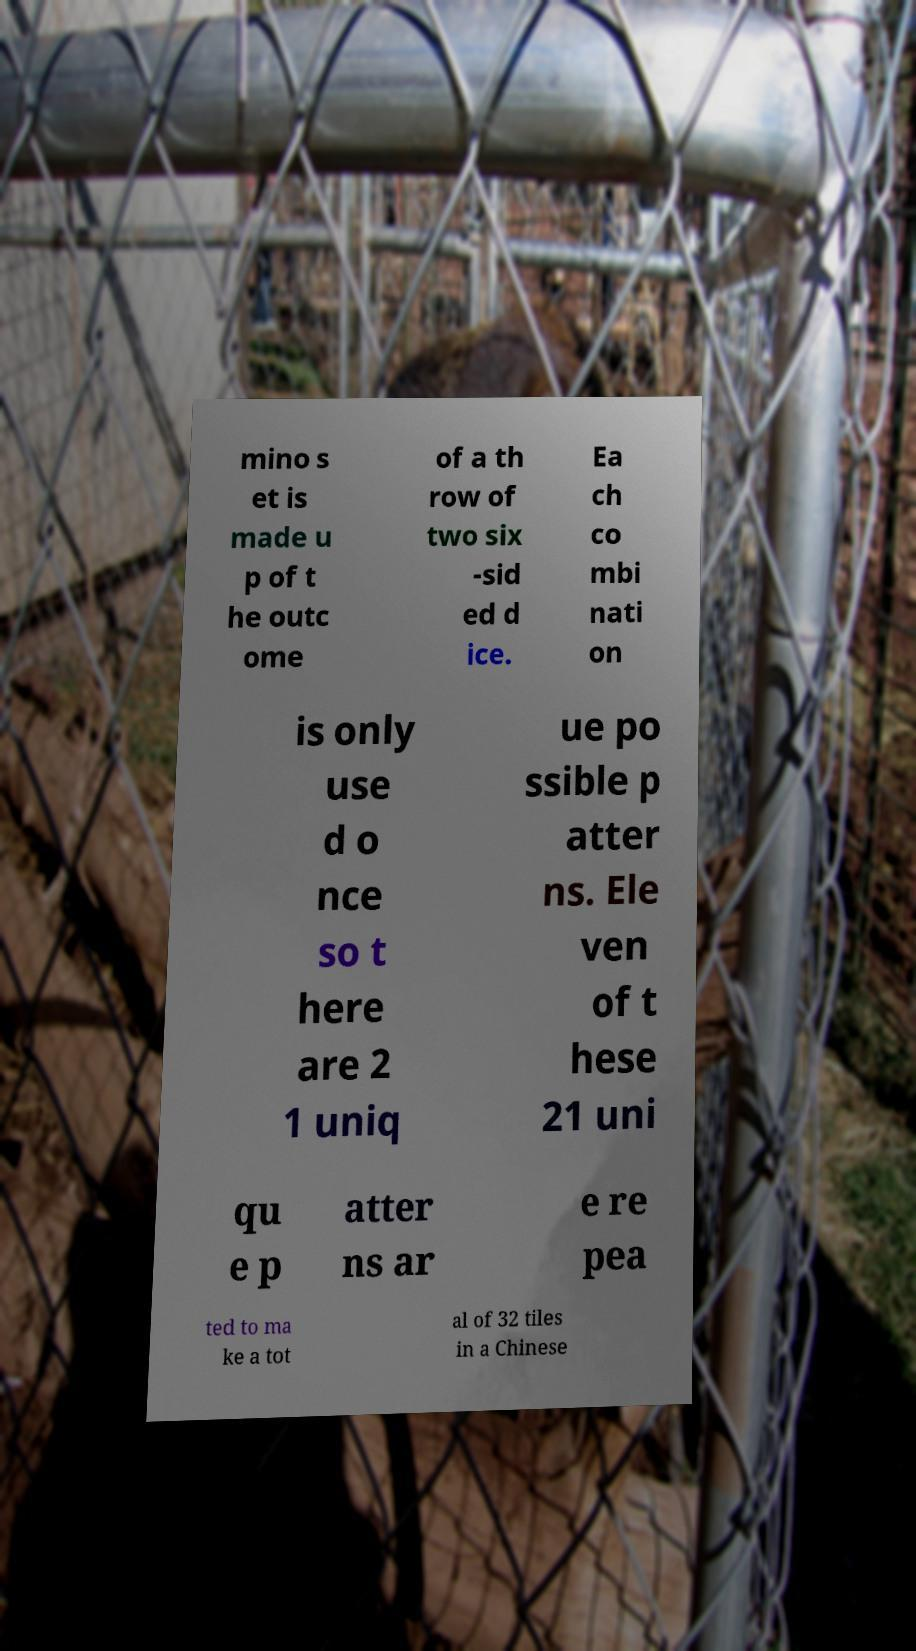Can you read and provide the text displayed in the image?This photo seems to have some interesting text. Can you extract and type it out for me? mino s et is made u p of t he outc ome of a th row of two six -sid ed d ice. Ea ch co mbi nati on is only use d o nce so t here are 2 1 uniq ue po ssible p atter ns. Ele ven of t hese 21 uni qu e p atter ns ar e re pea ted to ma ke a tot al of 32 tiles in a Chinese 